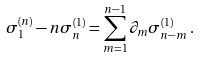<formula> <loc_0><loc_0><loc_500><loc_500>\sigma _ { 1 } ^ { ( n ) } - n \sigma _ { n } ^ { ( 1 ) } = \sum _ { m = 1 } ^ { n - 1 } \partial _ { m } \sigma _ { n - m } ^ { ( 1 ) } \, .</formula> 